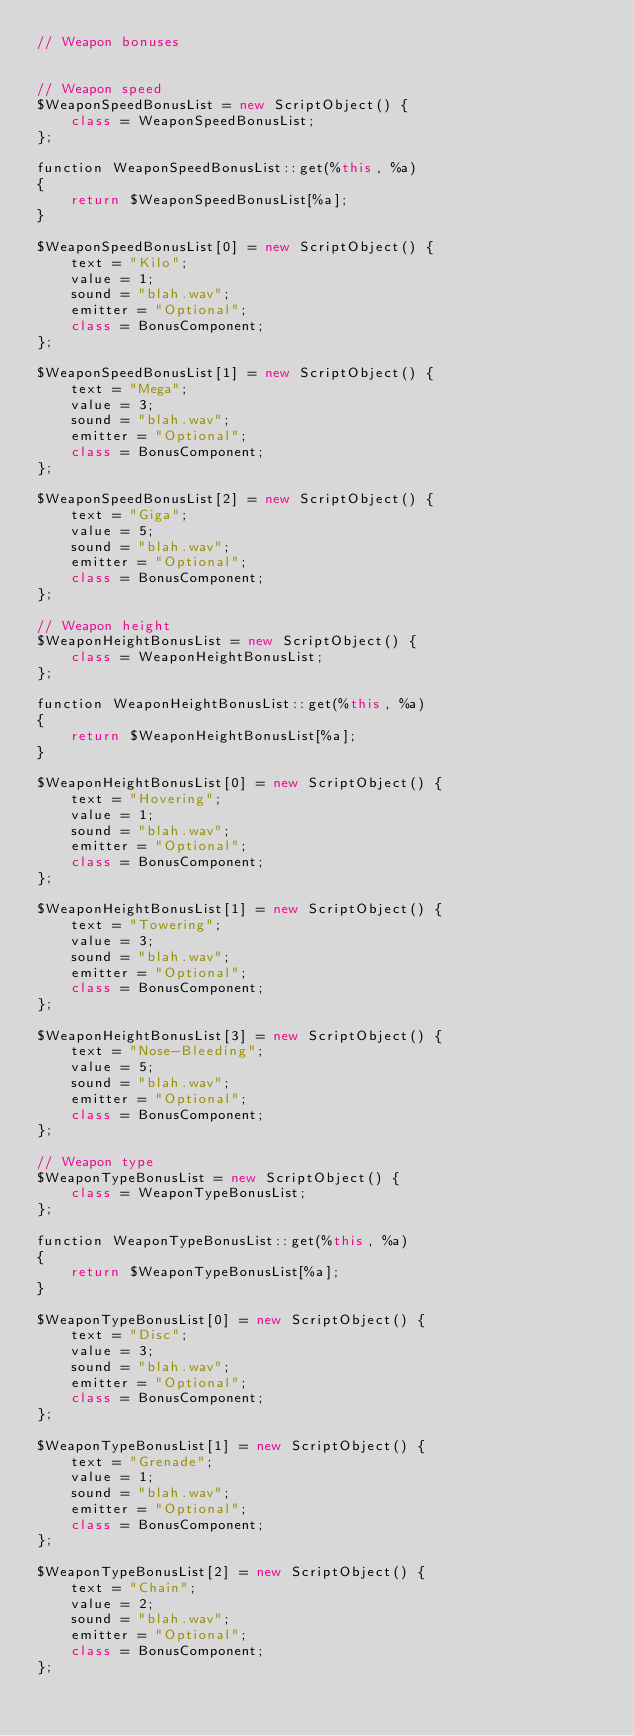Convert code to text. <code><loc_0><loc_0><loc_500><loc_500><_C#_>// Weapon bonuses


// Weapon speed
$WeaponSpeedBonusList = new ScriptObject() {
    class = WeaponSpeedBonusList;
};

function WeaponSpeedBonusList::get(%this, %a)
{
    return $WeaponSpeedBonusList[%a];
}

$WeaponSpeedBonusList[0] = new ScriptObject() {
    text = "Kilo";
    value = 1;
    sound = "blah.wav";
    emitter = "Optional";
    class = BonusComponent;
};

$WeaponSpeedBonusList[1] = new ScriptObject() {
    text = "Mega";
    value = 3;
    sound = "blah.wav";
    emitter = "Optional";
    class = BonusComponent;
};

$WeaponSpeedBonusList[2] = new ScriptObject() {
    text = "Giga";
    value = 5;
    sound = "blah.wav";
    emitter = "Optional";
    class = BonusComponent;
};

// Weapon height
$WeaponHeightBonusList = new ScriptObject() {
    class = WeaponHeightBonusList;
};

function WeaponHeightBonusList::get(%this, %a)
{
    return $WeaponHeightBonusList[%a];
}

$WeaponHeightBonusList[0] = new ScriptObject() {
    text = "Hovering";
    value = 1;
    sound = "blah.wav";
    emitter = "Optional";
    class = BonusComponent;
};

$WeaponHeightBonusList[1] = new ScriptObject() {
    text = "Towering";
    value = 3;
    sound = "blah.wav";
    emitter = "Optional";
    class = BonusComponent;
};

$WeaponHeightBonusList[3] = new ScriptObject() {
    text = "Nose-Bleeding";
    value = 5;
    sound = "blah.wav";
    emitter = "Optional";
    class = BonusComponent;
};

// Weapon type
$WeaponTypeBonusList = new ScriptObject() {
    class = WeaponTypeBonusList;
};

function WeaponTypeBonusList::get(%this, %a)
{
    return $WeaponTypeBonusList[%a];
}

$WeaponTypeBonusList[0] = new ScriptObject() {
    text = "Disc";
    value = 3;
    sound = "blah.wav";
    emitter = "Optional";
    class = BonusComponent;
};

$WeaponTypeBonusList[1] = new ScriptObject() {
    text = "Grenade";
    value = 1;
    sound = "blah.wav";
    emitter = "Optional";
    class = BonusComponent;
};

$WeaponTypeBonusList[2] = new ScriptObject() {
    text = "Chain";
    value = 2;
    sound = "blah.wav";
    emitter = "Optional";
    class = BonusComponent;
};
</code> 